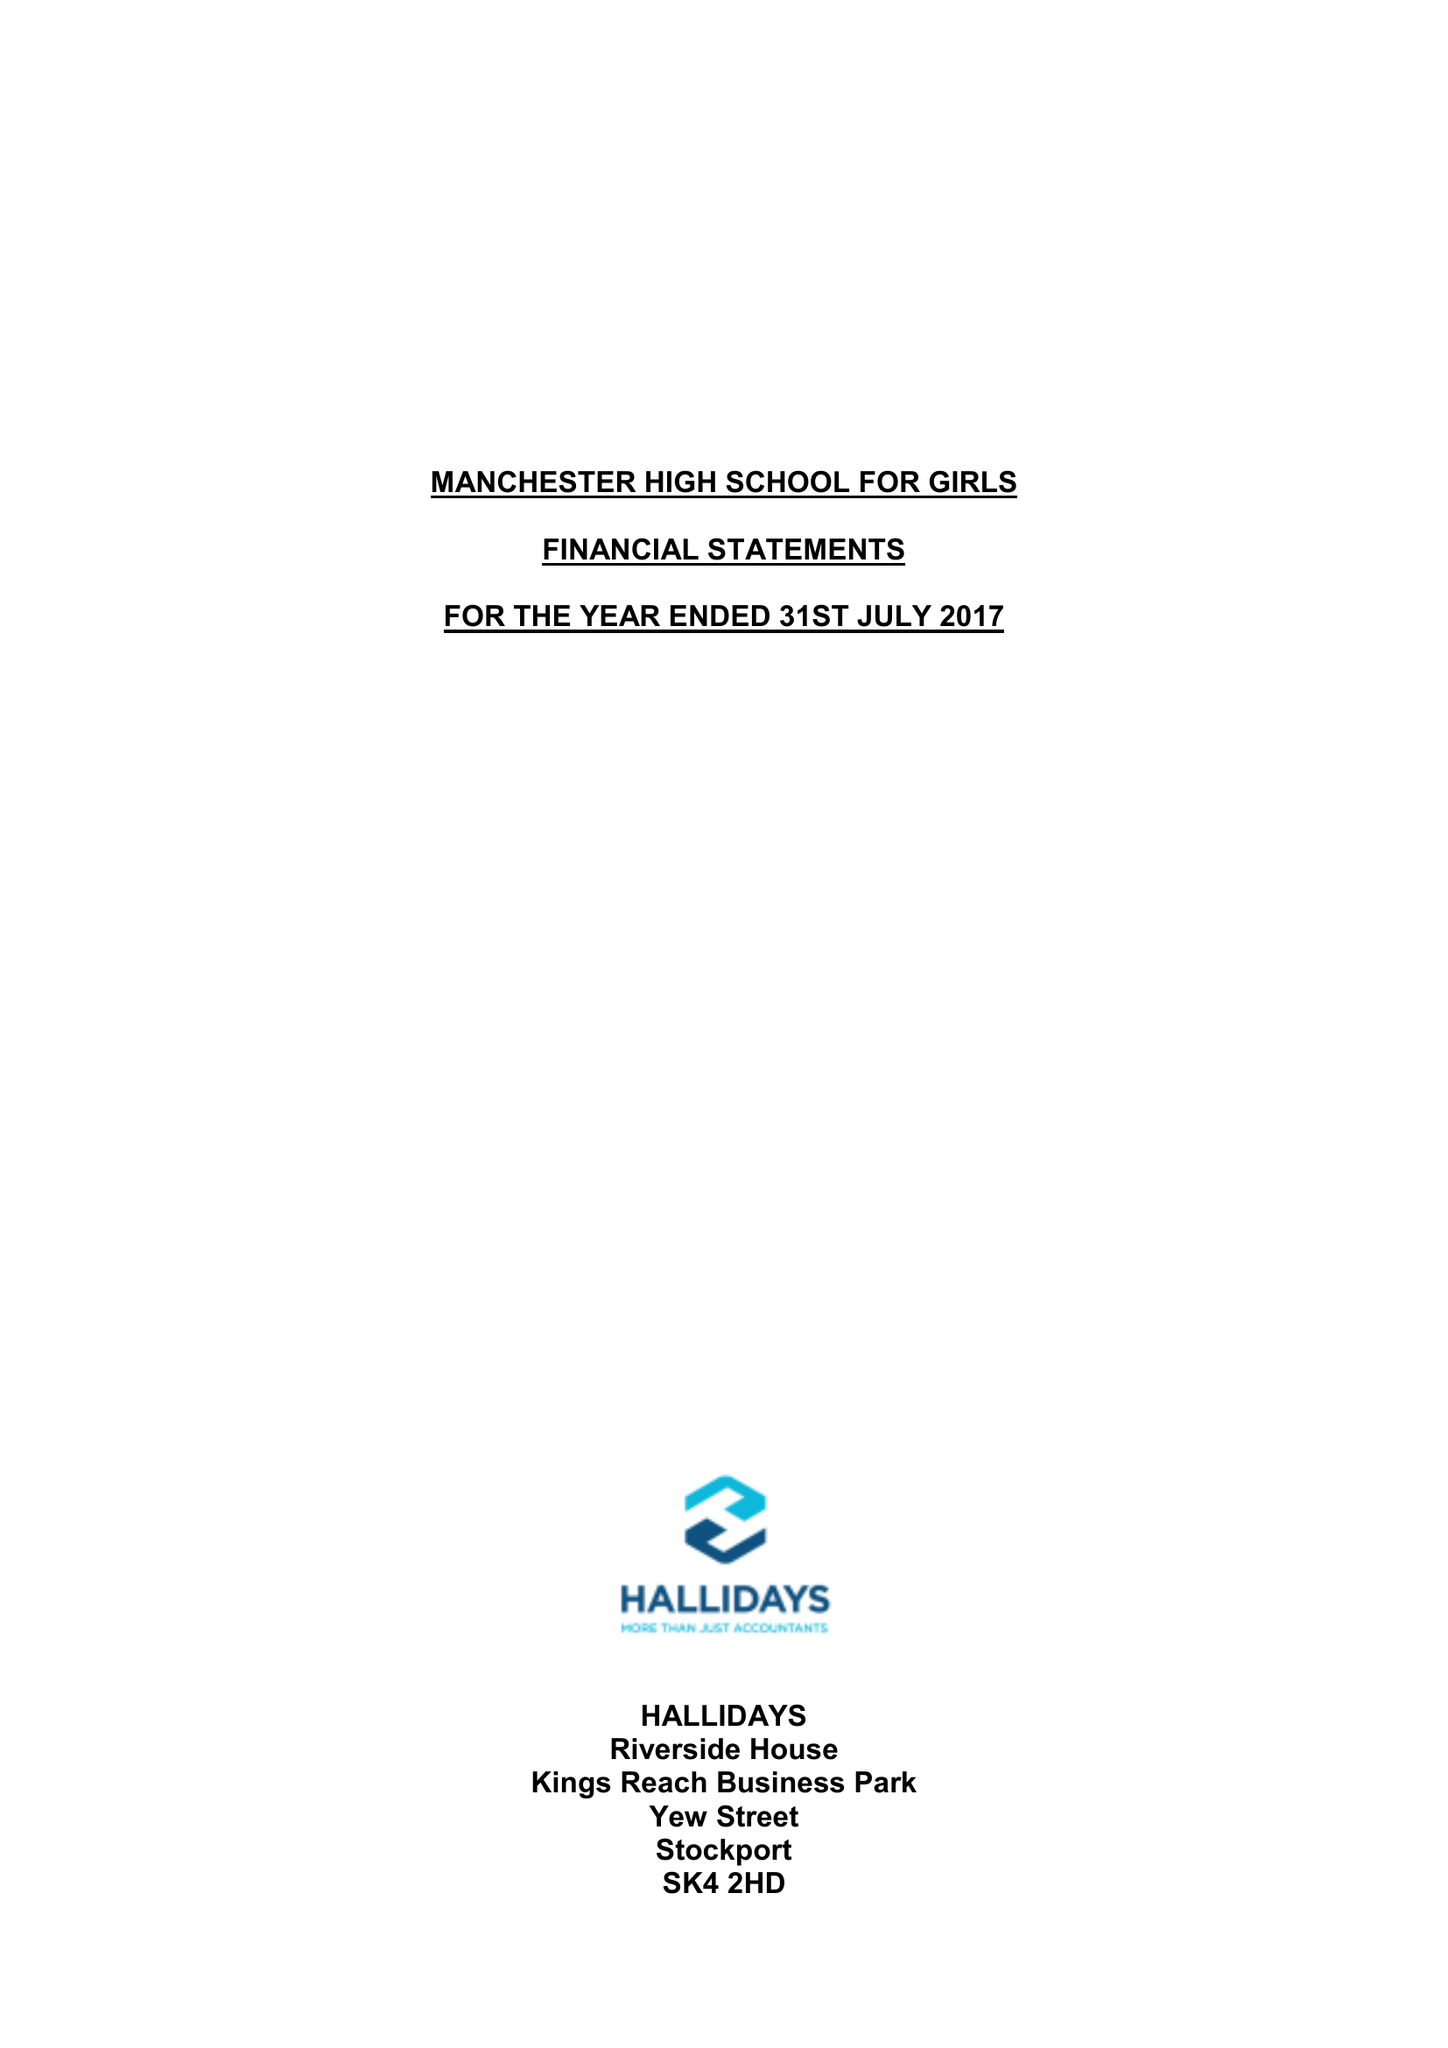What is the value for the report_date?
Answer the question using a single word or phrase. 2017-07-31 